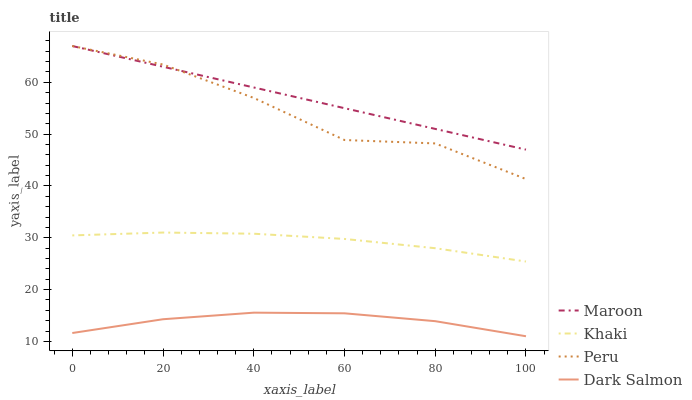Does Dark Salmon have the minimum area under the curve?
Answer yes or no. Yes. Does Maroon have the maximum area under the curve?
Answer yes or no. Yes. Does Peru have the minimum area under the curve?
Answer yes or no. No. Does Peru have the maximum area under the curve?
Answer yes or no. No. Is Maroon the smoothest?
Answer yes or no. Yes. Is Peru the roughest?
Answer yes or no. Yes. Is Peru the smoothest?
Answer yes or no. No. Is Maroon the roughest?
Answer yes or no. No. Does Dark Salmon have the lowest value?
Answer yes or no. Yes. Does Peru have the lowest value?
Answer yes or no. No. Does Maroon have the highest value?
Answer yes or no. Yes. Does Dark Salmon have the highest value?
Answer yes or no. No. Is Khaki less than Peru?
Answer yes or no. Yes. Is Khaki greater than Dark Salmon?
Answer yes or no. Yes. Does Peru intersect Maroon?
Answer yes or no. Yes. Is Peru less than Maroon?
Answer yes or no. No. Is Peru greater than Maroon?
Answer yes or no. No. Does Khaki intersect Peru?
Answer yes or no. No. 